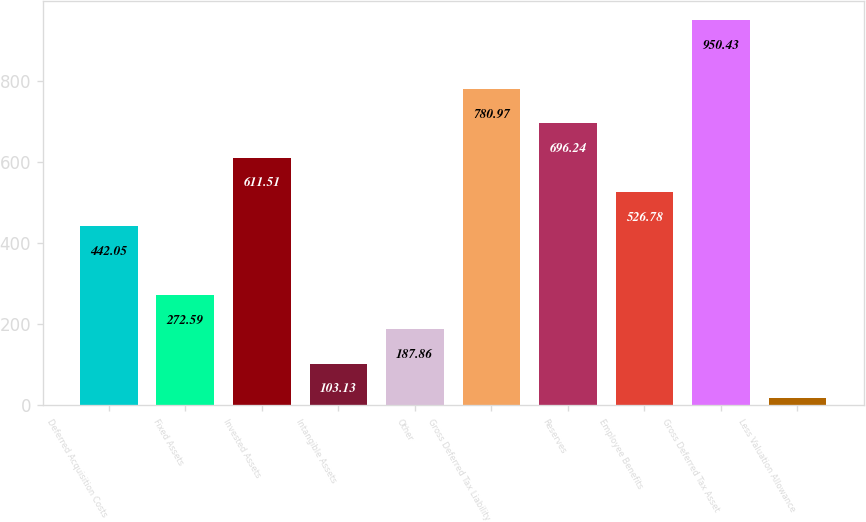Convert chart to OTSL. <chart><loc_0><loc_0><loc_500><loc_500><bar_chart><fcel>Deferred Acquisition Costs<fcel>Fixed Assets<fcel>Invested Assets<fcel>Intangible Assets<fcel>Other<fcel>Gross Deferred Tax Liability<fcel>Reserves<fcel>Employee Benefits<fcel>Gross Deferred Tax Asset<fcel>Less Valuation Allowance<nl><fcel>442.05<fcel>272.59<fcel>611.51<fcel>103.13<fcel>187.86<fcel>780.97<fcel>696.24<fcel>526.78<fcel>950.43<fcel>18.4<nl></chart> 